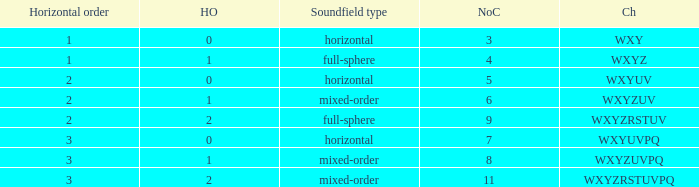If the channels is wxyzuv, what is the number of channels? 6.0. 